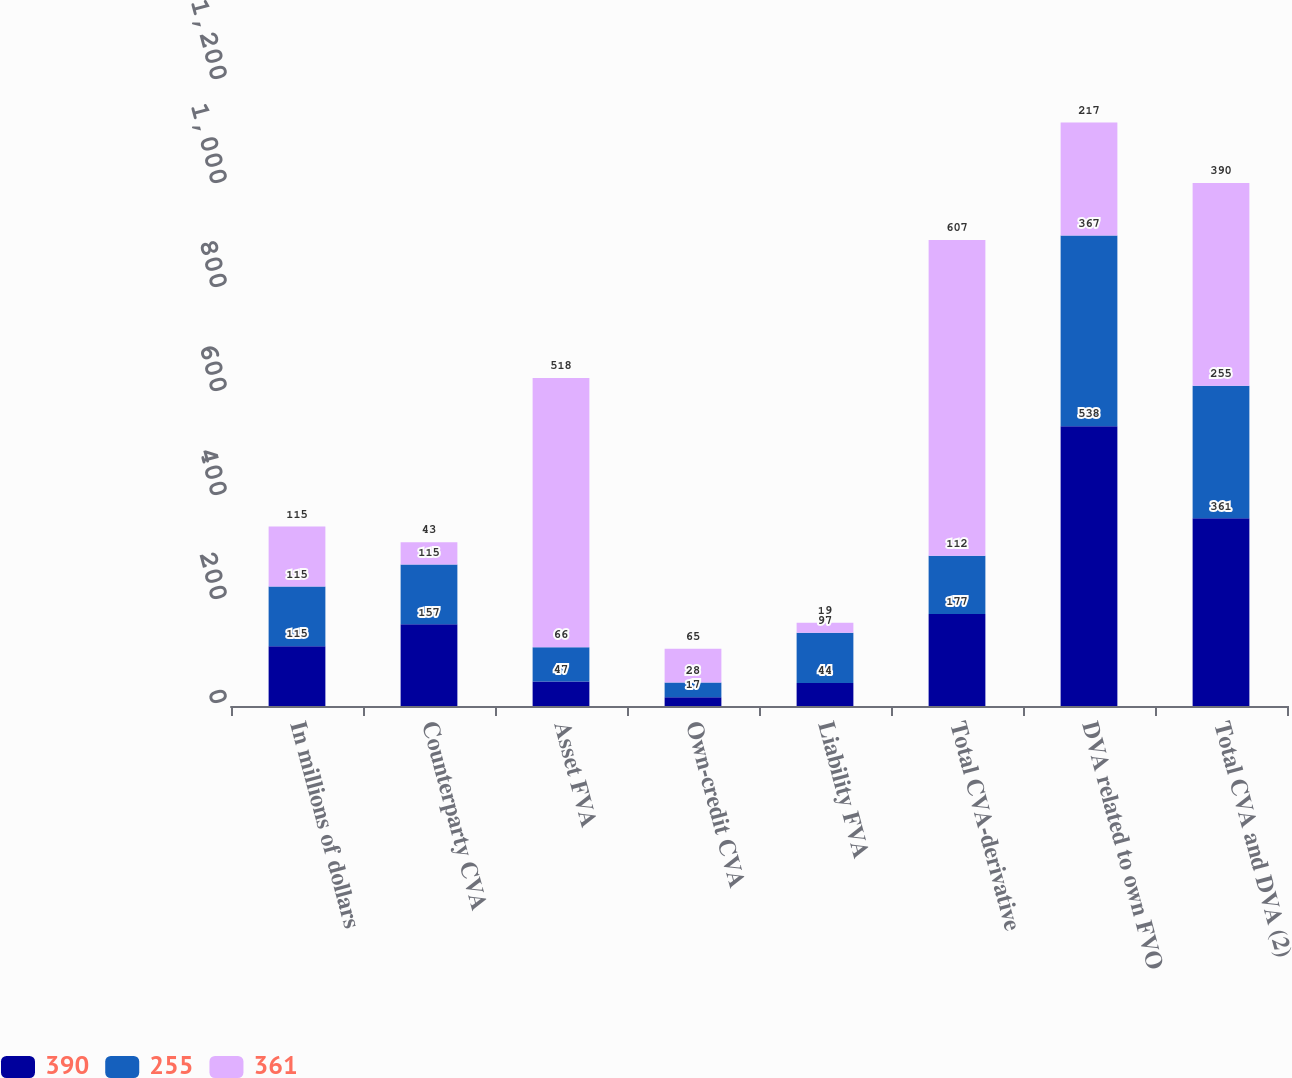<chart> <loc_0><loc_0><loc_500><loc_500><stacked_bar_chart><ecel><fcel>In millions of dollars<fcel>Counterparty CVA<fcel>Asset FVA<fcel>Own-credit CVA<fcel>Liability FVA<fcel>Total CVA-derivative<fcel>DVA related to own FVO<fcel>Total CVA and DVA (2)<nl><fcel>390<fcel>115<fcel>157<fcel>47<fcel>17<fcel>44<fcel>177<fcel>538<fcel>361<nl><fcel>255<fcel>115<fcel>115<fcel>66<fcel>28<fcel>97<fcel>112<fcel>367<fcel>255<nl><fcel>361<fcel>115<fcel>43<fcel>518<fcel>65<fcel>19<fcel>607<fcel>217<fcel>390<nl></chart> 